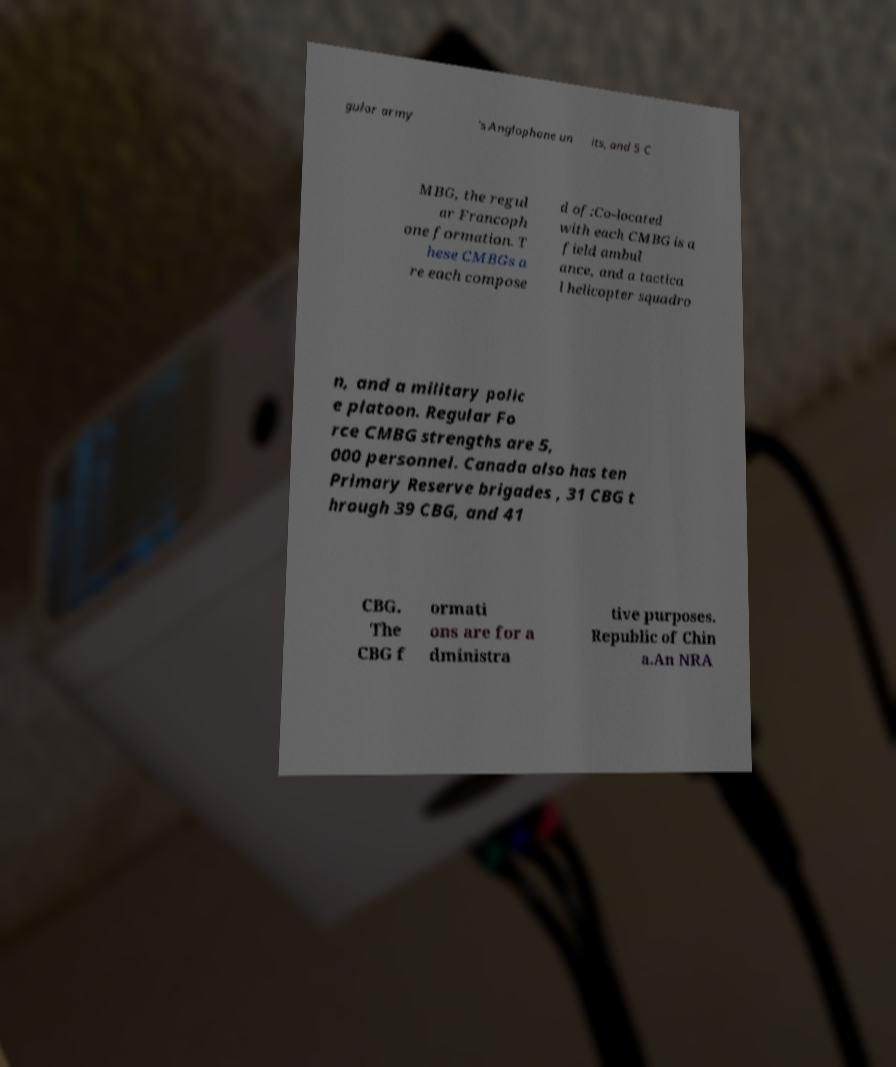Could you extract and type out the text from this image? gular army 's Anglophone un its, and 5 C MBG, the regul ar Francoph one formation. T hese CMBGs a re each compose d of:Co-located with each CMBG is a field ambul ance, and a tactica l helicopter squadro n, and a military polic e platoon. Regular Fo rce CMBG strengths are 5, 000 personnel. Canada also has ten Primary Reserve brigades , 31 CBG t hrough 39 CBG, and 41 CBG. The CBG f ormati ons are for a dministra tive purposes. Republic of Chin a.An NRA 